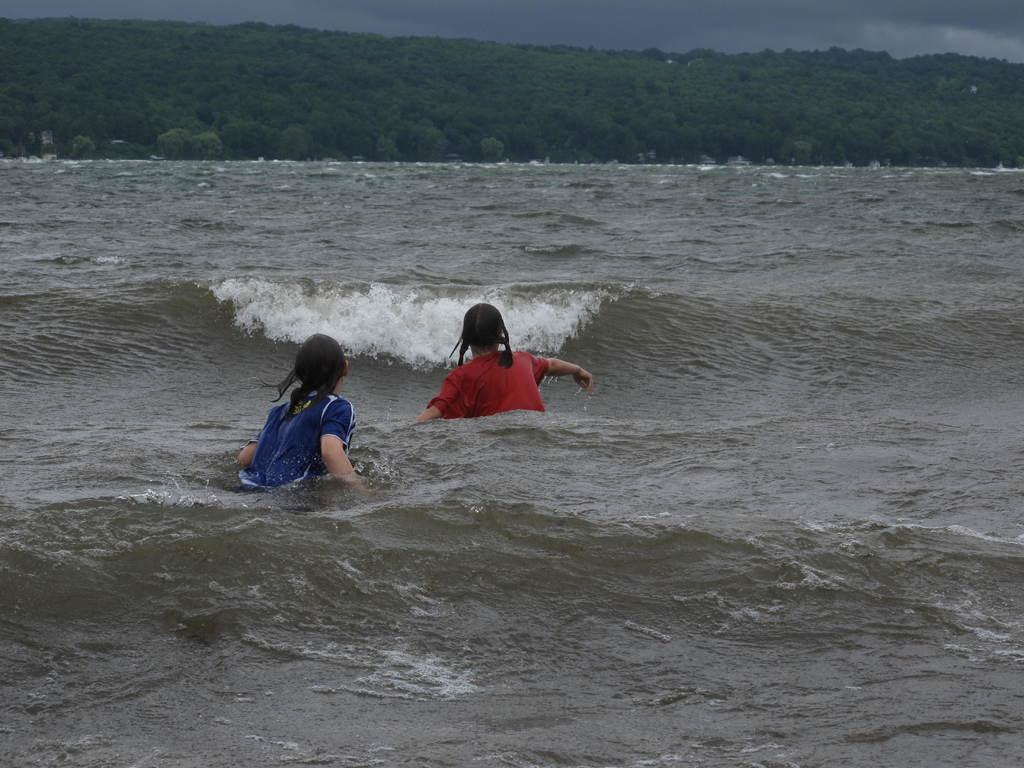How would you summarize this image in a sentence or two? In this image there are two women in the water having tides. Background there is a hill having trees. Top of the image there is sky. 